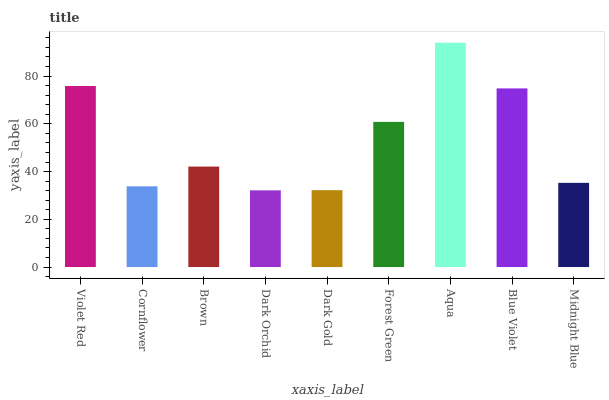Is Dark Orchid the minimum?
Answer yes or no. Yes. Is Aqua the maximum?
Answer yes or no. Yes. Is Cornflower the minimum?
Answer yes or no. No. Is Cornflower the maximum?
Answer yes or no. No. Is Violet Red greater than Cornflower?
Answer yes or no. Yes. Is Cornflower less than Violet Red?
Answer yes or no. Yes. Is Cornflower greater than Violet Red?
Answer yes or no. No. Is Violet Red less than Cornflower?
Answer yes or no. No. Is Brown the high median?
Answer yes or no. Yes. Is Brown the low median?
Answer yes or no. Yes. Is Aqua the high median?
Answer yes or no. No. Is Cornflower the low median?
Answer yes or no. No. 